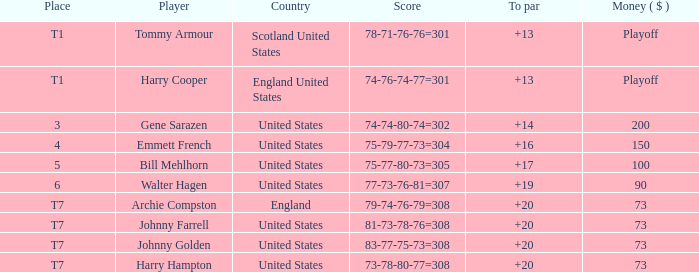What is the ranking for the United States when the money is $200? 3.0. 